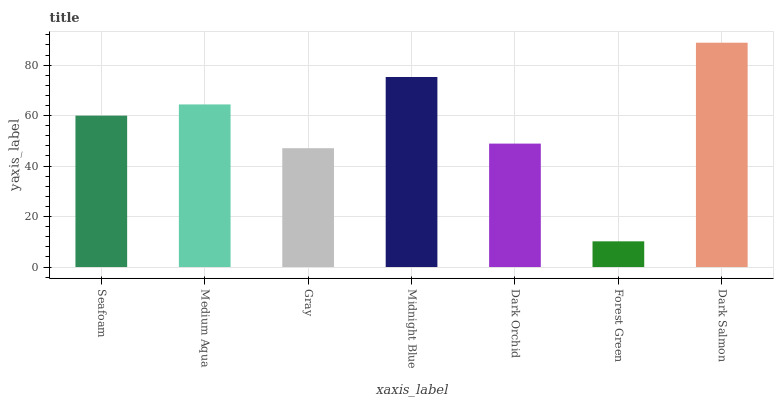Is Forest Green the minimum?
Answer yes or no. Yes. Is Dark Salmon the maximum?
Answer yes or no. Yes. Is Medium Aqua the minimum?
Answer yes or no. No. Is Medium Aqua the maximum?
Answer yes or no. No. Is Medium Aqua greater than Seafoam?
Answer yes or no. Yes. Is Seafoam less than Medium Aqua?
Answer yes or no. Yes. Is Seafoam greater than Medium Aqua?
Answer yes or no. No. Is Medium Aqua less than Seafoam?
Answer yes or no. No. Is Seafoam the high median?
Answer yes or no. Yes. Is Seafoam the low median?
Answer yes or no. Yes. Is Gray the high median?
Answer yes or no. No. Is Dark Salmon the low median?
Answer yes or no. No. 